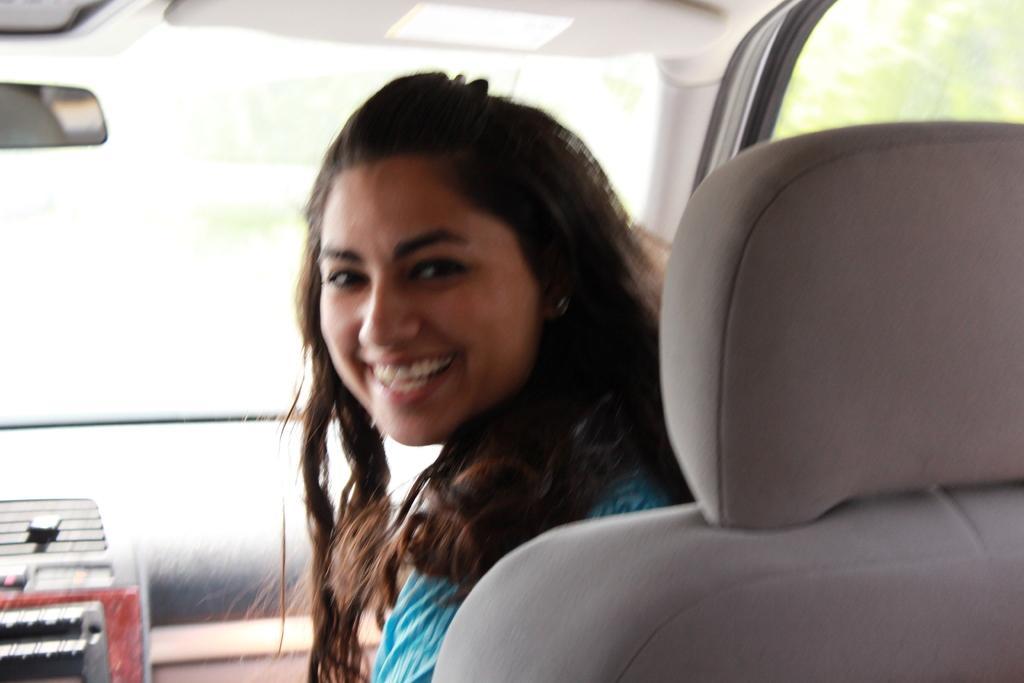In one or two sentences, can you explain what this image depicts? In the middle of the image a woman is sitting on a vehicle and smiling. 